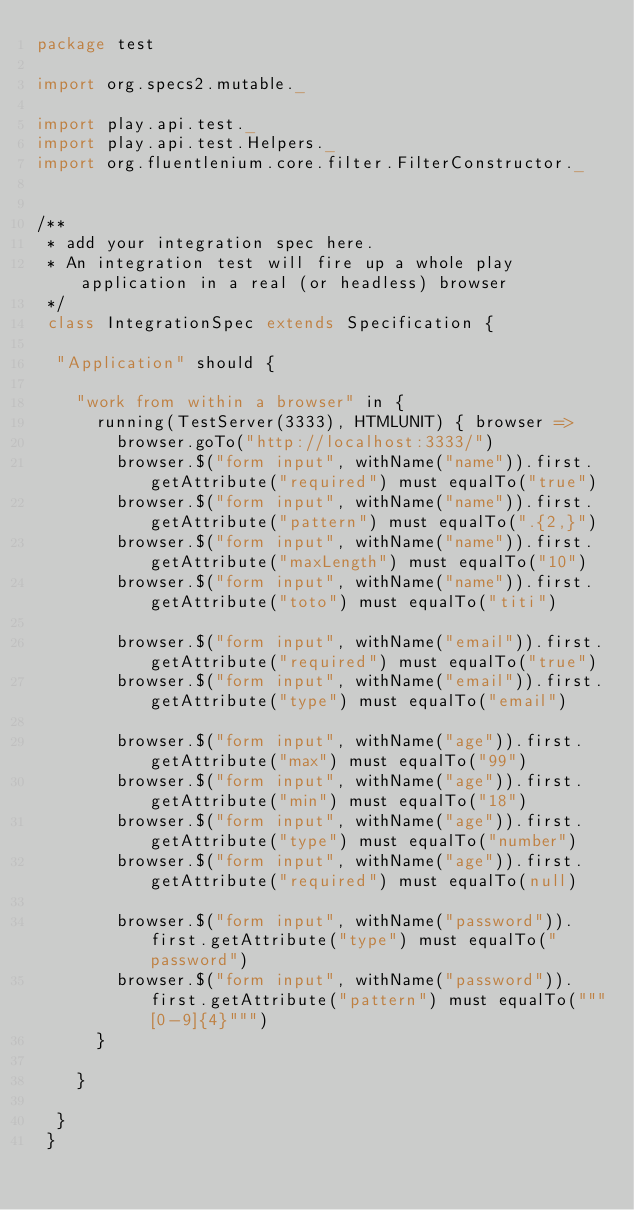<code> <loc_0><loc_0><loc_500><loc_500><_Scala_>package test

import org.specs2.mutable._

import play.api.test._
import play.api.test.Helpers._
import org.fluentlenium.core.filter.FilterConstructor._


/**
 * add your integration spec here.
 * An integration test will fire up a whole play application in a real (or headless) browser
 */
 class IntegrationSpec extends Specification {

 	"Application" should {

 		"work from within a browser" in {
 			running(TestServer(3333), HTMLUNIT) { browser =>
 				browser.goTo("http://localhost:3333/")
 				browser.$("form input", withName("name")).first.getAttribute("required") must equalTo("true")
 				browser.$("form input", withName("name")).first.getAttribute("pattern") must equalTo(".{2,}")
 				browser.$("form input", withName("name")).first.getAttribute("maxLength") must equalTo("10")
 				browser.$("form input", withName("name")).first.getAttribute("toto") must equalTo("titi")

 				browser.$("form input", withName("email")).first.getAttribute("required") must equalTo("true")
 				browser.$("form input", withName("email")).first.getAttribute("type") must equalTo("email")

 				browser.$("form input", withName("age")).first.getAttribute("max") must equalTo("99")
				browser.$("form input", withName("age")).first.getAttribute("min") must equalTo("18")
				browser.$("form input", withName("age")).first.getAttribute("type") must equalTo("number")
 				browser.$("form input", withName("age")).first.getAttribute("required") must equalTo(null)
 				
 				browser.$("form input", withName("password")).first.getAttribute("type") must equalTo("password")
 				browser.$("form input", withName("password")).first.getAttribute("pattern") must equalTo("""[0-9]{4}""")
 			}

 		}

 	}
 }</code> 